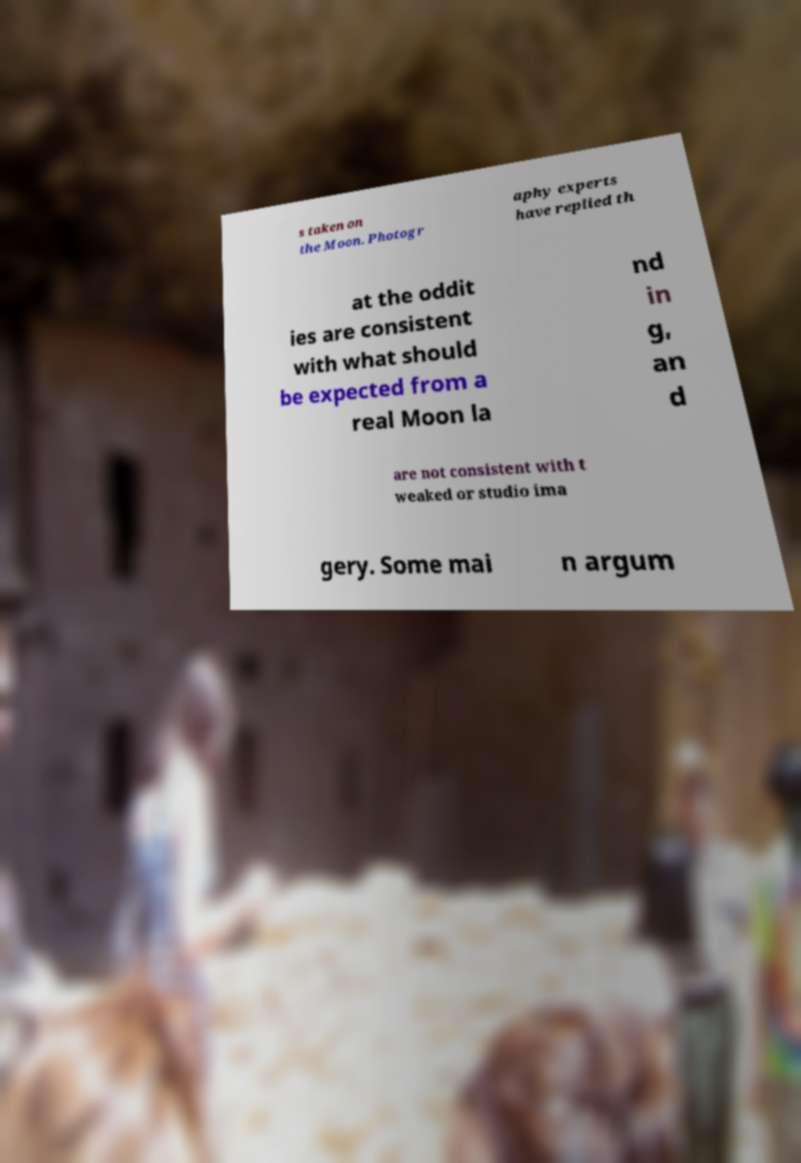Could you extract and type out the text from this image? s taken on the Moon. Photogr aphy experts have replied th at the oddit ies are consistent with what should be expected from a real Moon la nd in g, an d are not consistent with t weaked or studio ima gery. Some mai n argum 